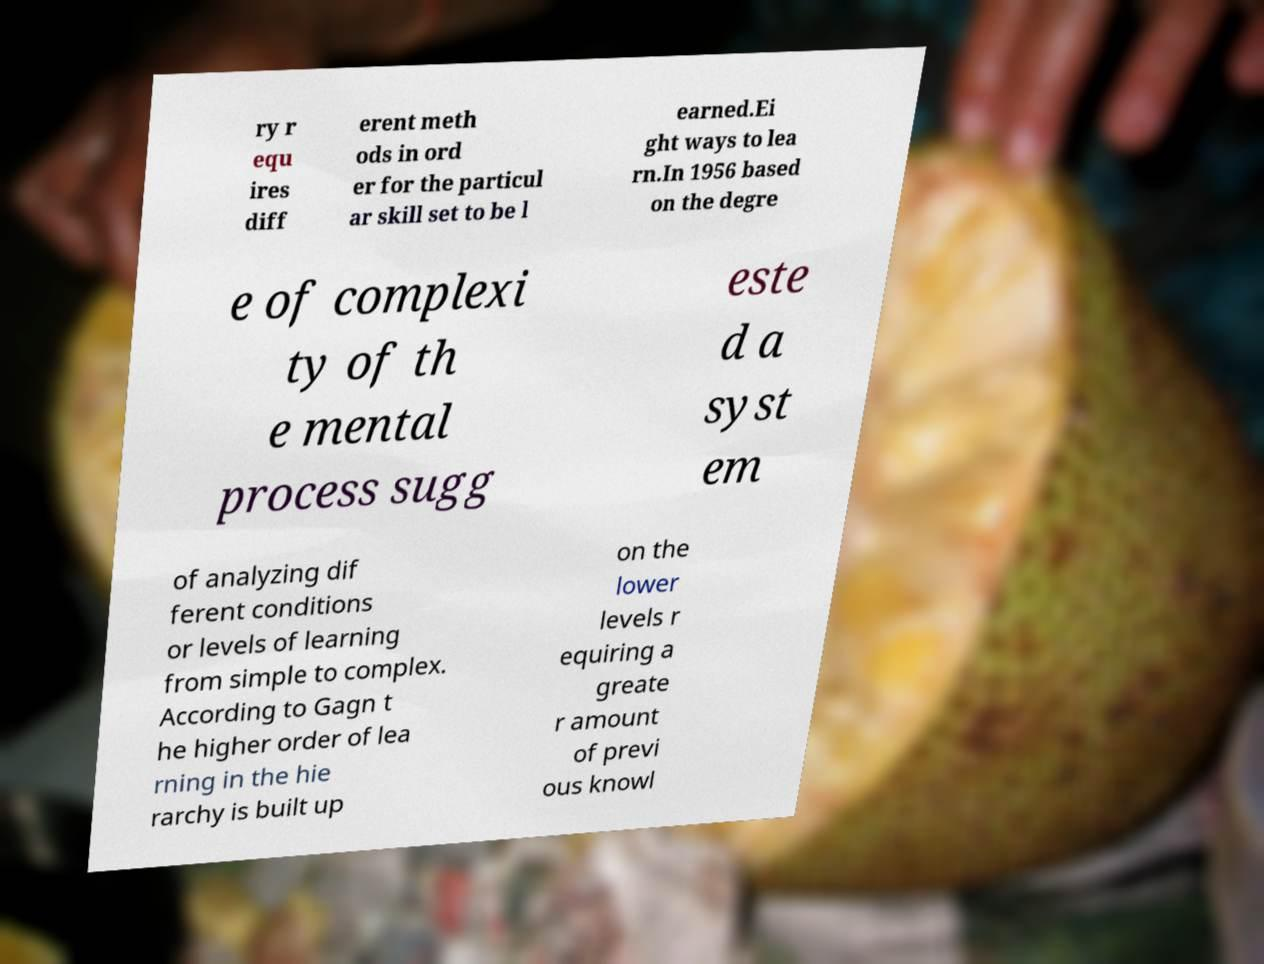Please read and relay the text visible in this image. What does it say? ry r equ ires diff erent meth ods in ord er for the particul ar skill set to be l earned.Ei ght ways to lea rn.In 1956 based on the degre e of complexi ty of th e mental process sugg este d a syst em of analyzing dif ferent conditions or levels of learning from simple to complex. According to Gagn t he higher order of lea rning in the hie rarchy is built up on the lower levels r equiring a greate r amount of previ ous knowl 